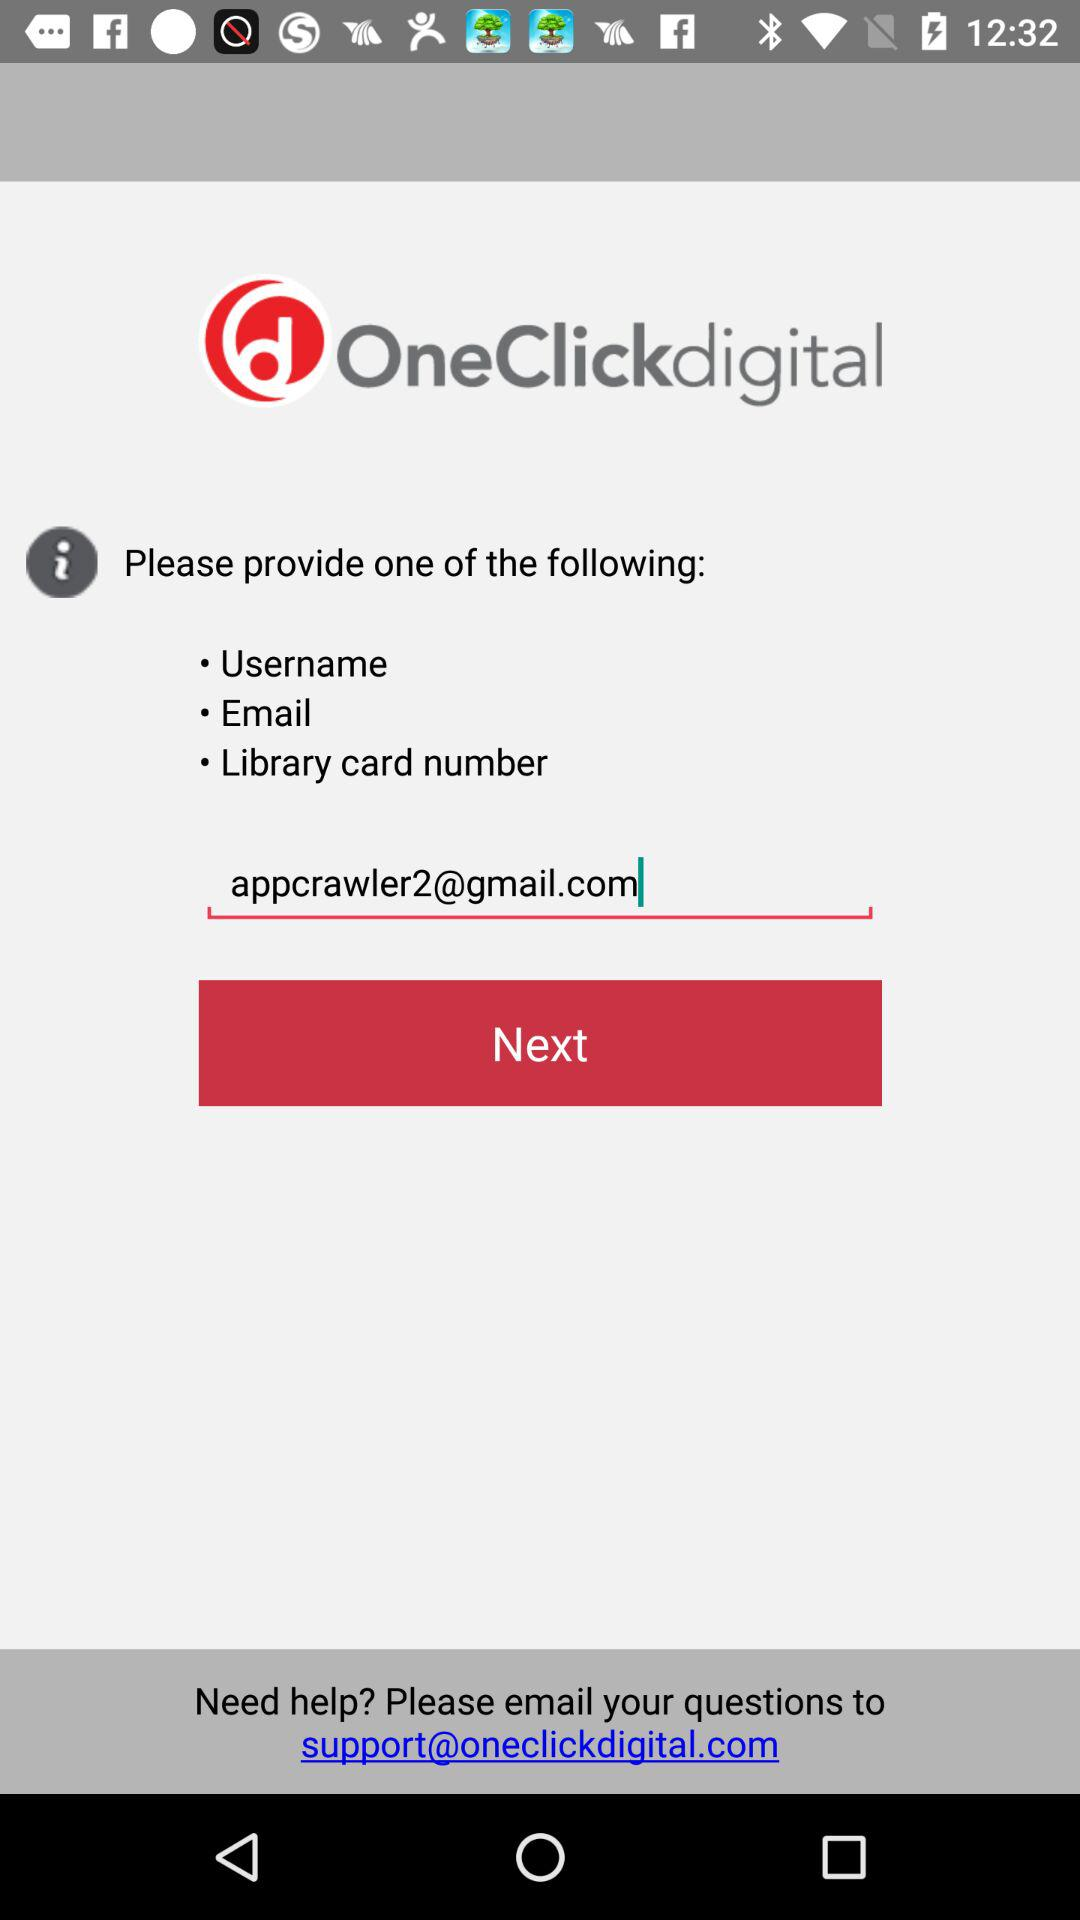What is the application name? The application name is "OneClickdigital". 